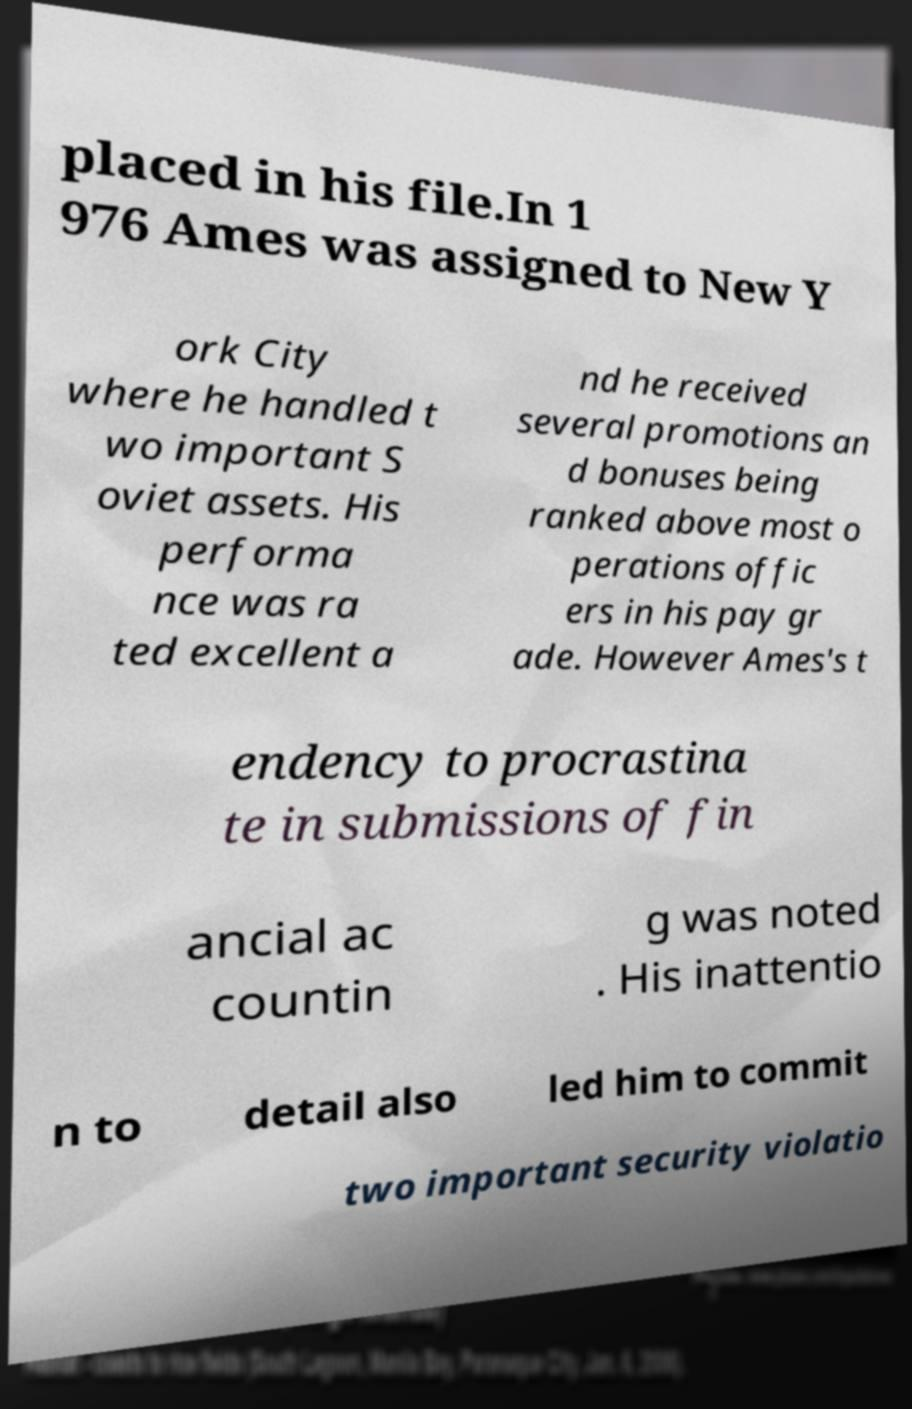Please read and relay the text visible in this image. What does it say? placed in his file.In 1 976 Ames was assigned to New Y ork City where he handled t wo important S oviet assets. His performa nce was ra ted excellent a nd he received several promotions an d bonuses being ranked above most o perations offic ers in his pay gr ade. However Ames's t endency to procrastina te in submissions of fin ancial ac countin g was noted . His inattentio n to detail also led him to commit two important security violatio 